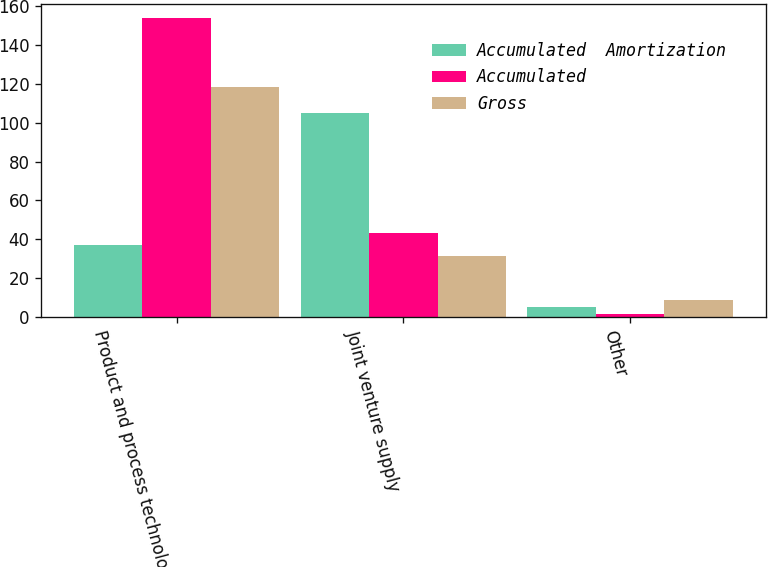<chart> <loc_0><loc_0><loc_500><loc_500><stacked_bar_chart><ecel><fcel>Product and process technology<fcel>Joint venture supply<fcel>Other<nl><fcel>Accumulated  Amortization<fcel>37.1<fcel>105<fcel>5.3<nl><fcel>Accumulated<fcel>153.6<fcel>43<fcel>1.7<nl><fcel>Gross<fcel>118.2<fcel>31.2<fcel>8.8<nl></chart> 